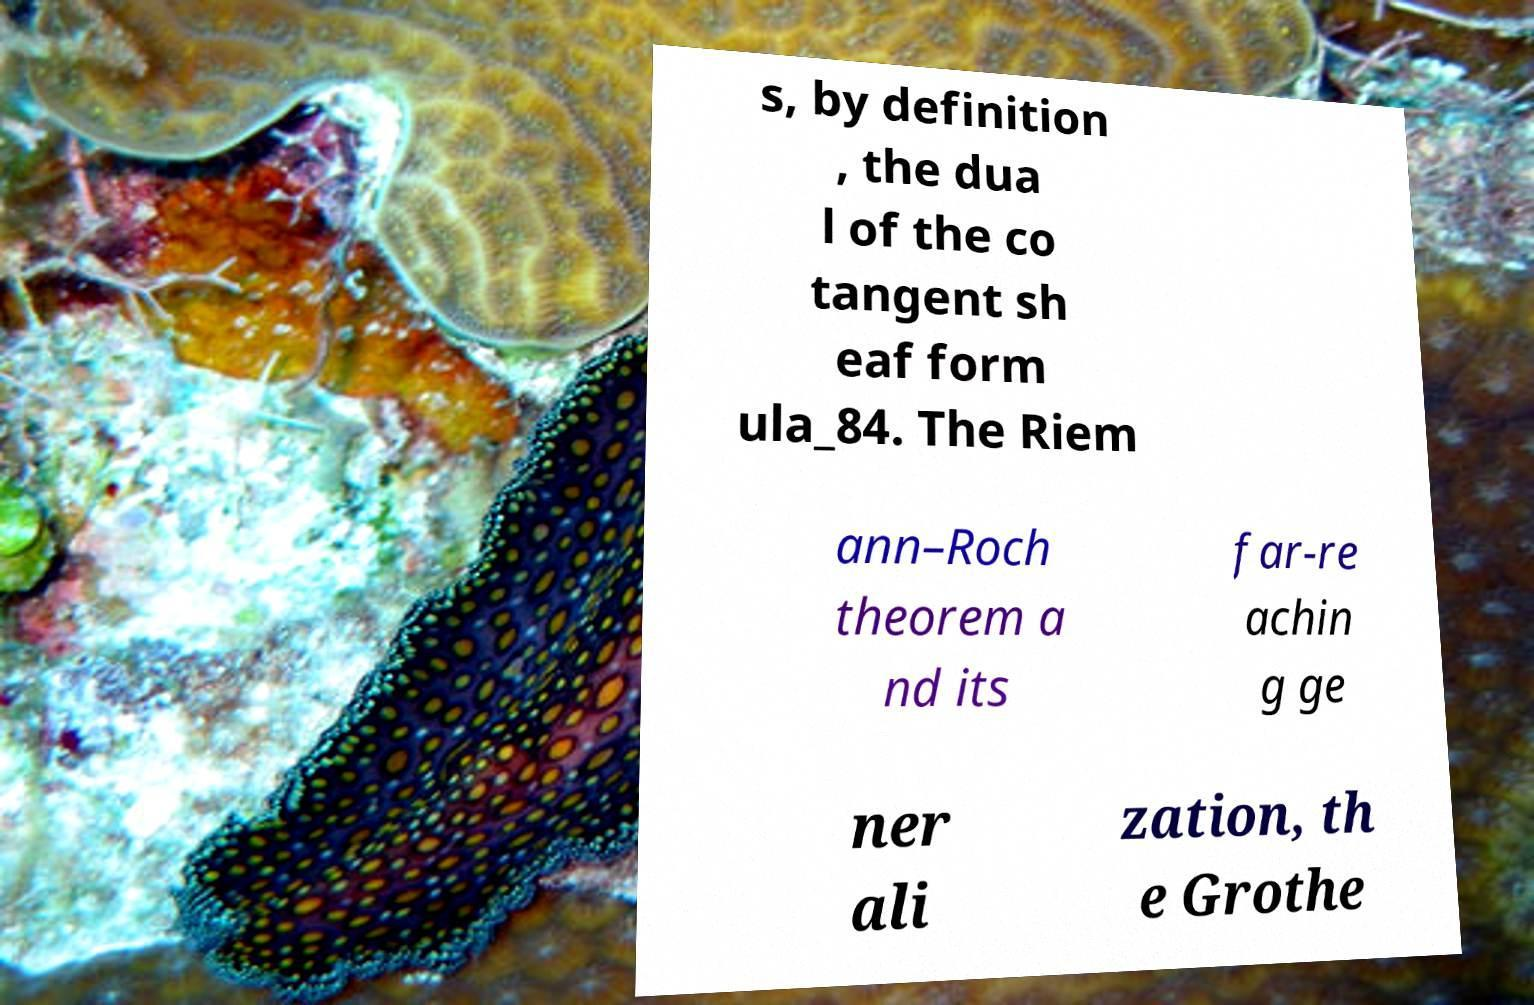Please identify and transcribe the text found in this image. s, by definition , the dua l of the co tangent sh eaf form ula_84. The Riem ann–Roch theorem a nd its far-re achin g ge ner ali zation, th e Grothe 